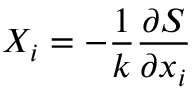<formula> <loc_0><loc_0><loc_500><loc_500>X _ { i } = - { \frac { 1 } { k } } { \frac { \partial S } { \partial x _ { i } } }</formula> 